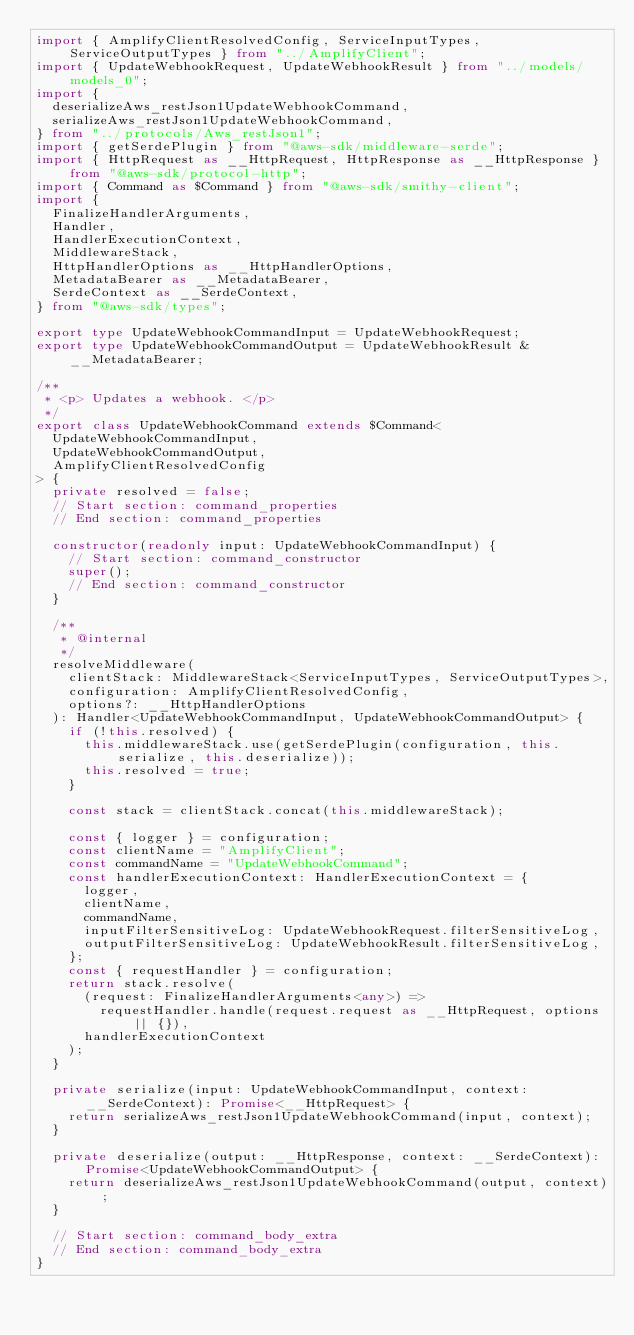Convert code to text. <code><loc_0><loc_0><loc_500><loc_500><_TypeScript_>import { AmplifyClientResolvedConfig, ServiceInputTypes, ServiceOutputTypes } from "../AmplifyClient";
import { UpdateWebhookRequest, UpdateWebhookResult } from "../models/models_0";
import {
  deserializeAws_restJson1UpdateWebhookCommand,
  serializeAws_restJson1UpdateWebhookCommand,
} from "../protocols/Aws_restJson1";
import { getSerdePlugin } from "@aws-sdk/middleware-serde";
import { HttpRequest as __HttpRequest, HttpResponse as __HttpResponse } from "@aws-sdk/protocol-http";
import { Command as $Command } from "@aws-sdk/smithy-client";
import {
  FinalizeHandlerArguments,
  Handler,
  HandlerExecutionContext,
  MiddlewareStack,
  HttpHandlerOptions as __HttpHandlerOptions,
  MetadataBearer as __MetadataBearer,
  SerdeContext as __SerdeContext,
} from "@aws-sdk/types";

export type UpdateWebhookCommandInput = UpdateWebhookRequest;
export type UpdateWebhookCommandOutput = UpdateWebhookResult & __MetadataBearer;

/**
 * <p> Updates a webhook. </p>
 */
export class UpdateWebhookCommand extends $Command<
  UpdateWebhookCommandInput,
  UpdateWebhookCommandOutput,
  AmplifyClientResolvedConfig
> {
  private resolved = false;
  // Start section: command_properties
  // End section: command_properties

  constructor(readonly input: UpdateWebhookCommandInput) {
    // Start section: command_constructor
    super();
    // End section: command_constructor
  }

  /**
   * @internal
   */
  resolveMiddleware(
    clientStack: MiddlewareStack<ServiceInputTypes, ServiceOutputTypes>,
    configuration: AmplifyClientResolvedConfig,
    options?: __HttpHandlerOptions
  ): Handler<UpdateWebhookCommandInput, UpdateWebhookCommandOutput> {
    if (!this.resolved) {
      this.middlewareStack.use(getSerdePlugin(configuration, this.serialize, this.deserialize));
      this.resolved = true;
    }

    const stack = clientStack.concat(this.middlewareStack);

    const { logger } = configuration;
    const clientName = "AmplifyClient";
    const commandName = "UpdateWebhookCommand";
    const handlerExecutionContext: HandlerExecutionContext = {
      logger,
      clientName,
      commandName,
      inputFilterSensitiveLog: UpdateWebhookRequest.filterSensitiveLog,
      outputFilterSensitiveLog: UpdateWebhookResult.filterSensitiveLog,
    };
    const { requestHandler } = configuration;
    return stack.resolve(
      (request: FinalizeHandlerArguments<any>) =>
        requestHandler.handle(request.request as __HttpRequest, options || {}),
      handlerExecutionContext
    );
  }

  private serialize(input: UpdateWebhookCommandInput, context: __SerdeContext): Promise<__HttpRequest> {
    return serializeAws_restJson1UpdateWebhookCommand(input, context);
  }

  private deserialize(output: __HttpResponse, context: __SerdeContext): Promise<UpdateWebhookCommandOutput> {
    return deserializeAws_restJson1UpdateWebhookCommand(output, context);
  }

  // Start section: command_body_extra
  // End section: command_body_extra
}
</code> 